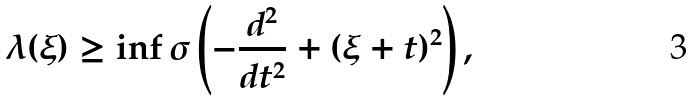Convert formula to latex. <formula><loc_0><loc_0><loc_500><loc_500>\lambda ( \xi ) \geq \inf \sigma \left ( - \frac { d ^ { 2 } } { d t ^ { 2 } } + ( \xi + t ) ^ { 2 } \right ) ,</formula> 